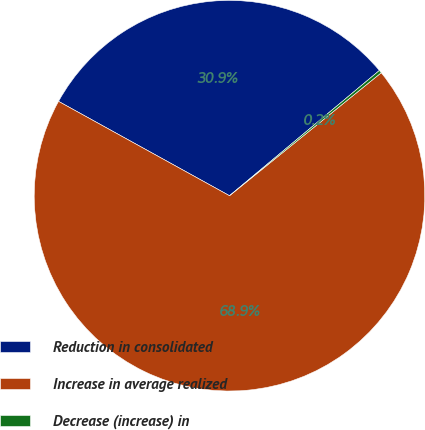Convert chart. <chart><loc_0><loc_0><loc_500><loc_500><pie_chart><fcel>Reduction in consolidated<fcel>Increase in average realized<fcel>Decrease (increase) in<nl><fcel>30.89%<fcel>68.86%<fcel>0.24%<nl></chart> 